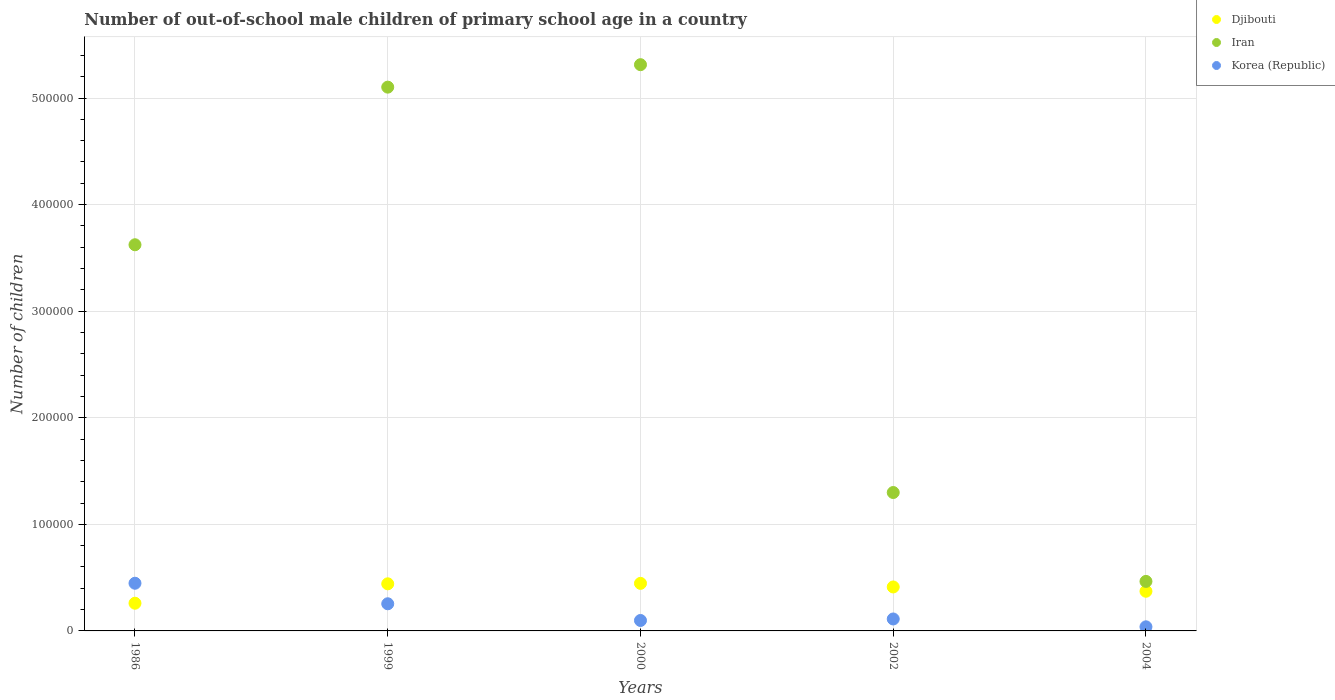What is the number of out-of-school male children in Iran in 2002?
Give a very brief answer. 1.30e+05. Across all years, what is the maximum number of out-of-school male children in Djibouti?
Give a very brief answer. 4.46e+04. Across all years, what is the minimum number of out-of-school male children in Djibouti?
Keep it short and to the point. 2.60e+04. In which year was the number of out-of-school male children in Djibouti minimum?
Your response must be concise. 1986. What is the total number of out-of-school male children in Djibouti in the graph?
Your answer should be very brief. 1.93e+05. What is the difference between the number of out-of-school male children in Korea (Republic) in 1999 and that in 2004?
Your answer should be compact. 2.16e+04. What is the difference between the number of out-of-school male children in Korea (Republic) in 1986 and the number of out-of-school male children in Djibouti in 2000?
Make the answer very short. 118. What is the average number of out-of-school male children in Korea (Republic) per year?
Ensure brevity in your answer.  1.90e+04. In the year 1999, what is the difference between the number of out-of-school male children in Korea (Republic) and number of out-of-school male children in Iran?
Ensure brevity in your answer.  -4.85e+05. What is the ratio of the number of out-of-school male children in Djibouti in 1999 to that in 2000?
Provide a short and direct response. 0.99. Is the number of out-of-school male children in Korea (Republic) in 1999 less than that in 2002?
Provide a succinct answer. No. What is the difference between the highest and the second highest number of out-of-school male children in Iran?
Your answer should be very brief. 2.11e+04. What is the difference between the highest and the lowest number of out-of-school male children in Korea (Republic)?
Make the answer very short. 4.09e+04. Does the number of out-of-school male children in Iran monotonically increase over the years?
Provide a succinct answer. No. Is the number of out-of-school male children in Korea (Republic) strictly less than the number of out-of-school male children in Djibouti over the years?
Make the answer very short. No. Does the graph contain any zero values?
Provide a succinct answer. No. How are the legend labels stacked?
Keep it short and to the point. Vertical. What is the title of the graph?
Your answer should be compact. Number of out-of-school male children of primary school age in a country. Does "Madagascar" appear as one of the legend labels in the graph?
Your response must be concise. No. What is the label or title of the X-axis?
Keep it short and to the point. Years. What is the label or title of the Y-axis?
Provide a succinct answer. Number of children. What is the Number of children in Djibouti in 1986?
Offer a very short reply. 2.60e+04. What is the Number of children in Iran in 1986?
Offer a terse response. 3.62e+05. What is the Number of children in Korea (Republic) in 1986?
Your answer should be compact. 4.47e+04. What is the Number of children of Djibouti in 1999?
Your answer should be very brief. 4.42e+04. What is the Number of children in Iran in 1999?
Provide a short and direct response. 5.10e+05. What is the Number of children of Korea (Republic) in 1999?
Ensure brevity in your answer.  2.55e+04. What is the Number of children in Djibouti in 2000?
Keep it short and to the point. 4.46e+04. What is the Number of children of Iran in 2000?
Ensure brevity in your answer.  5.31e+05. What is the Number of children of Korea (Republic) in 2000?
Your answer should be very brief. 9803. What is the Number of children of Djibouti in 2002?
Your answer should be compact. 4.12e+04. What is the Number of children of Iran in 2002?
Offer a terse response. 1.30e+05. What is the Number of children of Korea (Republic) in 2002?
Your response must be concise. 1.12e+04. What is the Number of children in Djibouti in 2004?
Keep it short and to the point. 3.72e+04. What is the Number of children in Iran in 2004?
Your answer should be compact. 4.65e+04. What is the Number of children of Korea (Republic) in 2004?
Offer a very short reply. 3851. Across all years, what is the maximum Number of children of Djibouti?
Offer a terse response. 4.46e+04. Across all years, what is the maximum Number of children in Iran?
Your answer should be compact. 5.31e+05. Across all years, what is the maximum Number of children in Korea (Republic)?
Your answer should be very brief. 4.47e+04. Across all years, what is the minimum Number of children of Djibouti?
Offer a very short reply. 2.60e+04. Across all years, what is the minimum Number of children in Iran?
Your response must be concise. 4.65e+04. Across all years, what is the minimum Number of children in Korea (Republic)?
Make the answer very short. 3851. What is the total Number of children of Djibouti in the graph?
Offer a terse response. 1.93e+05. What is the total Number of children in Iran in the graph?
Provide a succinct answer. 1.58e+06. What is the total Number of children in Korea (Republic) in the graph?
Your answer should be compact. 9.51e+04. What is the difference between the Number of children in Djibouti in 1986 and that in 1999?
Your answer should be very brief. -1.82e+04. What is the difference between the Number of children in Iran in 1986 and that in 1999?
Your answer should be very brief. -1.48e+05. What is the difference between the Number of children in Korea (Republic) in 1986 and that in 1999?
Your response must be concise. 1.93e+04. What is the difference between the Number of children in Djibouti in 1986 and that in 2000?
Offer a terse response. -1.86e+04. What is the difference between the Number of children in Iran in 1986 and that in 2000?
Give a very brief answer. -1.69e+05. What is the difference between the Number of children in Korea (Republic) in 1986 and that in 2000?
Ensure brevity in your answer.  3.49e+04. What is the difference between the Number of children in Djibouti in 1986 and that in 2002?
Make the answer very short. -1.53e+04. What is the difference between the Number of children of Iran in 1986 and that in 2002?
Offer a terse response. 2.32e+05. What is the difference between the Number of children of Korea (Republic) in 1986 and that in 2002?
Keep it short and to the point. 3.35e+04. What is the difference between the Number of children in Djibouti in 1986 and that in 2004?
Offer a terse response. -1.12e+04. What is the difference between the Number of children of Iran in 1986 and that in 2004?
Provide a succinct answer. 3.16e+05. What is the difference between the Number of children in Korea (Republic) in 1986 and that in 2004?
Ensure brevity in your answer.  4.09e+04. What is the difference between the Number of children in Djibouti in 1999 and that in 2000?
Ensure brevity in your answer.  -418. What is the difference between the Number of children in Iran in 1999 and that in 2000?
Give a very brief answer. -2.11e+04. What is the difference between the Number of children in Korea (Republic) in 1999 and that in 2000?
Your answer should be compact. 1.57e+04. What is the difference between the Number of children in Djibouti in 1999 and that in 2002?
Your response must be concise. 2945. What is the difference between the Number of children in Iran in 1999 and that in 2002?
Offer a terse response. 3.80e+05. What is the difference between the Number of children in Korea (Republic) in 1999 and that in 2002?
Keep it short and to the point. 1.43e+04. What is the difference between the Number of children in Djibouti in 1999 and that in 2004?
Provide a short and direct response. 6983. What is the difference between the Number of children in Iran in 1999 and that in 2004?
Provide a succinct answer. 4.64e+05. What is the difference between the Number of children in Korea (Republic) in 1999 and that in 2004?
Your answer should be very brief. 2.16e+04. What is the difference between the Number of children of Djibouti in 2000 and that in 2002?
Provide a succinct answer. 3363. What is the difference between the Number of children in Iran in 2000 and that in 2002?
Offer a terse response. 4.01e+05. What is the difference between the Number of children in Korea (Republic) in 2000 and that in 2002?
Provide a succinct answer. -1402. What is the difference between the Number of children in Djibouti in 2000 and that in 2004?
Keep it short and to the point. 7401. What is the difference between the Number of children of Iran in 2000 and that in 2004?
Your answer should be compact. 4.85e+05. What is the difference between the Number of children of Korea (Republic) in 2000 and that in 2004?
Offer a very short reply. 5952. What is the difference between the Number of children in Djibouti in 2002 and that in 2004?
Offer a very short reply. 4038. What is the difference between the Number of children of Iran in 2002 and that in 2004?
Provide a short and direct response. 8.34e+04. What is the difference between the Number of children in Korea (Republic) in 2002 and that in 2004?
Your answer should be very brief. 7354. What is the difference between the Number of children in Djibouti in 1986 and the Number of children in Iran in 1999?
Keep it short and to the point. -4.84e+05. What is the difference between the Number of children of Djibouti in 1986 and the Number of children of Korea (Republic) in 1999?
Provide a succinct answer. 509. What is the difference between the Number of children in Iran in 1986 and the Number of children in Korea (Republic) in 1999?
Keep it short and to the point. 3.37e+05. What is the difference between the Number of children in Djibouti in 1986 and the Number of children in Iran in 2000?
Ensure brevity in your answer.  -5.05e+05. What is the difference between the Number of children in Djibouti in 1986 and the Number of children in Korea (Republic) in 2000?
Provide a short and direct response. 1.62e+04. What is the difference between the Number of children of Iran in 1986 and the Number of children of Korea (Republic) in 2000?
Provide a succinct answer. 3.53e+05. What is the difference between the Number of children in Djibouti in 1986 and the Number of children in Iran in 2002?
Ensure brevity in your answer.  -1.04e+05. What is the difference between the Number of children in Djibouti in 1986 and the Number of children in Korea (Republic) in 2002?
Offer a terse response. 1.48e+04. What is the difference between the Number of children in Iran in 1986 and the Number of children in Korea (Republic) in 2002?
Your response must be concise. 3.51e+05. What is the difference between the Number of children in Djibouti in 1986 and the Number of children in Iran in 2004?
Keep it short and to the point. -2.05e+04. What is the difference between the Number of children in Djibouti in 1986 and the Number of children in Korea (Republic) in 2004?
Your response must be concise. 2.21e+04. What is the difference between the Number of children of Iran in 1986 and the Number of children of Korea (Republic) in 2004?
Offer a very short reply. 3.58e+05. What is the difference between the Number of children of Djibouti in 1999 and the Number of children of Iran in 2000?
Your response must be concise. -4.87e+05. What is the difference between the Number of children of Djibouti in 1999 and the Number of children of Korea (Republic) in 2000?
Your response must be concise. 3.44e+04. What is the difference between the Number of children in Iran in 1999 and the Number of children in Korea (Republic) in 2000?
Keep it short and to the point. 5.00e+05. What is the difference between the Number of children in Djibouti in 1999 and the Number of children in Iran in 2002?
Keep it short and to the point. -8.57e+04. What is the difference between the Number of children in Djibouti in 1999 and the Number of children in Korea (Republic) in 2002?
Ensure brevity in your answer.  3.30e+04. What is the difference between the Number of children of Iran in 1999 and the Number of children of Korea (Republic) in 2002?
Make the answer very short. 4.99e+05. What is the difference between the Number of children of Djibouti in 1999 and the Number of children of Iran in 2004?
Your answer should be compact. -2266. What is the difference between the Number of children in Djibouti in 1999 and the Number of children in Korea (Republic) in 2004?
Give a very brief answer. 4.03e+04. What is the difference between the Number of children of Iran in 1999 and the Number of children of Korea (Republic) in 2004?
Provide a succinct answer. 5.06e+05. What is the difference between the Number of children in Djibouti in 2000 and the Number of children in Iran in 2002?
Make the answer very short. -8.52e+04. What is the difference between the Number of children of Djibouti in 2000 and the Number of children of Korea (Republic) in 2002?
Ensure brevity in your answer.  3.34e+04. What is the difference between the Number of children of Iran in 2000 and the Number of children of Korea (Republic) in 2002?
Your answer should be compact. 5.20e+05. What is the difference between the Number of children in Djibouti in 2000 and the Number of children in Iran in 2004?
Your answer should be compact. -1848. What is the difference between the Number of children in Djibouti in 2000 and the Number of children in Korea (Republic) in 2004?
Your response must be concise. 4.08e+04. What is the difference between the Number of children of Iran in 2000 and the Number of children of Korea (Republic) in 2004?
Offer a very short reply. 5.27e+05. What is the difference between the Number of children of Djibouti in 2002 and the Number of children of Iran in 2004?
Your response must be concise. -5211. What is the difference between the Number of children in Djibouti in 2002 and the Number of children in Korea (Republic) in 2004?
Provide a succinct answer. 3.74e+04. What is the difference between the Number of children in Iran in 2002 and the Number of children in Korea (Republic) in 2004?
Provide a succinct answer. 1.26e+05. What is the average Number of children of Djibouti per year?
Give a very brief answer. 3.86e+04. What is the average Number of children of Iran per year?
Offer a very short reply. 3.16e+05. What is the average Number of children of Korea (Republic) per year?
Offer a terse response. 1.90e+04. In the year 1986, what is the difference between the Number of children in Djibouti and Number of children in Iran?
Your answer should be compact. -3.36e+05. In the year 1986, what is the difference between the Number of children of Djibouti and Number of children of Korea (Republic)?
Ensure brevity in your answer.  -1.87e+04. In the year 1986, what is the difference between the Number of children in Iran and Number of children in Korea (Republic)?
Provide a short and direct response. 3.18e+05. In the year 1999, what is the difference between the Number of children of Djibouti and Number of children of Iran?
Offer a very short reply. -4.66e+05. In the year 1999, what is the difference between the Number of children of Djibouti and Number of children of Korea (Republic)?
Provide a succinct answer. 1.87e+04. In the year 1999, what is the difference between the Number of children in Iran and Number of children in Korea (Republic)?
Your answer should be very brief. 4.85e+05. In the year 2000, what is the difference between the Number of children in Djibouti and Number of children in Iran?
Offer a very short reply. -4.87e+05. In the year 2000, what is the difference between the Number of children in Djibouti and Number of children in Korea (Republic)?
Your answer should be compact. 3.48e+04. In the year 2000, what is the difference between the Number of children of Iran and Number of children of Korea (Republic)?
Your response must be concise. 5.21e+05. In the year 2002, what is the difference between the Number of children in Djibouti and Number of children in Iran?
Your answer should be compact. -8.86e+04. In the year 2002, what is the difference between the Number of children of Djibouti and Number of children of Korea (Republic)?
Ensure brevity in your answer.  3.00e+04. In the year 2002, what is the difference between the Number of children in Iran and Number of children in Korea (Republic)?
Give a very brief answer. 1.19e+05. In the year 2004, what is the difference between the Number of children in Djibouti and Number of children in Iran?
Ensure brevity in your answer.  -9249. In the year 2004, what is the difference between the Number of children of Djibouti and Number of children of Korea (Republic)?
Offer a terse response. 3.34e+04. In the year 2004, what is the difference between the Number of children of Iran and Number of children of Korea (Republic)?
Your answer should be compact. 4.26e+04. What is the ratio of the Number of children in Djibouti in 1986 to that in 1999?
Make the answer very short. 0.59. What is the ratio of the Number of children of Iran in 1986 to that in 1999?
Offer a very short reply. 0.71. What is the ratio of the Number of children in Korea (Republic) in 1986 to that in 1999?
Your response must be concise. 1.76. What is the ratio of the Number of children of Djibouti in 1986 to that in 2000?
Make the answer very short. 0.58. What is the ratio of the Number of children in Iran in 1986 to that in 2000?
Offer a very short reply. 0.68. What is the ratio of the Number of children in Korea (Republic) in 1986 to that in 2000?
Offer a terse response. 4.56. What is the ratio of the Number of children in Djibouti in 1986 to that in 2002?
Give a very brief answer. 0.63. What is the ratio of the Number of children in Iran in 1986 to that in 2002?
Offer a very short reply. 2.79. What is the ratio of the Number of children in Korea (Republic) in 1986 to that in 2002?
Ensure brevity in your answer.  3.99. What is the ratio of the Number of children of Djibouti in 1986 to that in 2004?
Your answer should be compact. 0.7. What is the ratio of the Number of children in Iran in 1986 to that in 2004?
Make the answer very short. 7.8. What is the ratio of the Number of children in Korea (Republic) in 1986 to that in 2004?
Your answer should be very brief. 11.61. What is the ratio of the Number of children of Djibouti in 1999 to that in 2000?
Make the answer very short. 0.99. What is the ratio of the Number of children in Iran in 1999 to that in 2000?
Give a very brief answer. 0.96. What is the ratio of the Number of children of Korea (Republic) in 1999 to that in 2000?
Provide a succinct answer. 2.6. What is the ratio of the Number of children in Djibouti in 1999 to that in 2002?
Offer a terse response. 1.07. What is the ratio of the Number of children of Iran in 1999 to that in 2002?
Your answer should be compact. 3.93. What is the ratio of the Number of children in Korea (Republic) in 1999 to that in 2002?
Ensure brevity in your answer.  2.27. What is the ratio of the Number of children in Djibouti in 1999 to that in 2004?
Ensure brevity in your answer.  1.19. What is the ratio of the Number of children of Iran in 1999 to that in 2004?
Your answer should be very brief. 10.98. What is the ratio of the Number of children in Korea (Republic) in 1999 to that in 2004?
Provide a short and direct response. 6.61. What is the ratio of the Number of children of Djibouti in 2000 to that in 2002?
Your answer should be very brief. 1.08. What is the ratio of the Number of children of Iran in 2000 to that in 2002?
Ensure brevity in your answer.  4.09. What is the ratio of the Number of children of Korea (Republic) in 2000 to that in 2002?
Your answer should be very brief. 0.87. What is the ratio of the Number of children of Djibouti in 2000 to that in 2004?
Offer a very short reply. 1.2. What is the ratio of the Number of children of Iran in 2000 to that in 2004?
Provide a succinct answer. 11.44. What is the ratio of the Number of children in Korea (Republic) in 2000 to that in 2004?
Ensure brevity in your answer.  2.55. What is the ratio of the Number of children of Djibouti in 2002 to that in 2004?
Offer a terse response. 1.11. What is the ratio of the Number of children of Iran in 2002 to that in 2004?
Provide a short and direct response. 2.8. What is the ratio of the Number of children of Korea (Republic) in 2002 to that in 2004?
Offer a very short reply. 2.91. What is the difference between the highest and the second highest Number of children of Djibouti?
Keep it short and to the point. 418. What is the difference between the highest and the second highest Number of children in Iran?
Offer a terse response. 2.11e+04. What is the difference between the highest and the second highest Number of children of Korea (Republic)?
Offer a very short reply. 1.93e+04. What is the difference between the highest and the lowest Number of children in Djibouti?
Keep it short and to the point. 1.86e+04. What is the difference between the highest and the lowest Number of children in Iran?
Offer a very short reply. 4.85e+05. What is the difference between the highest and the lowest Number of children of Korea (Republic)?
Ensure brevity in your answer.  4.09e+04. 